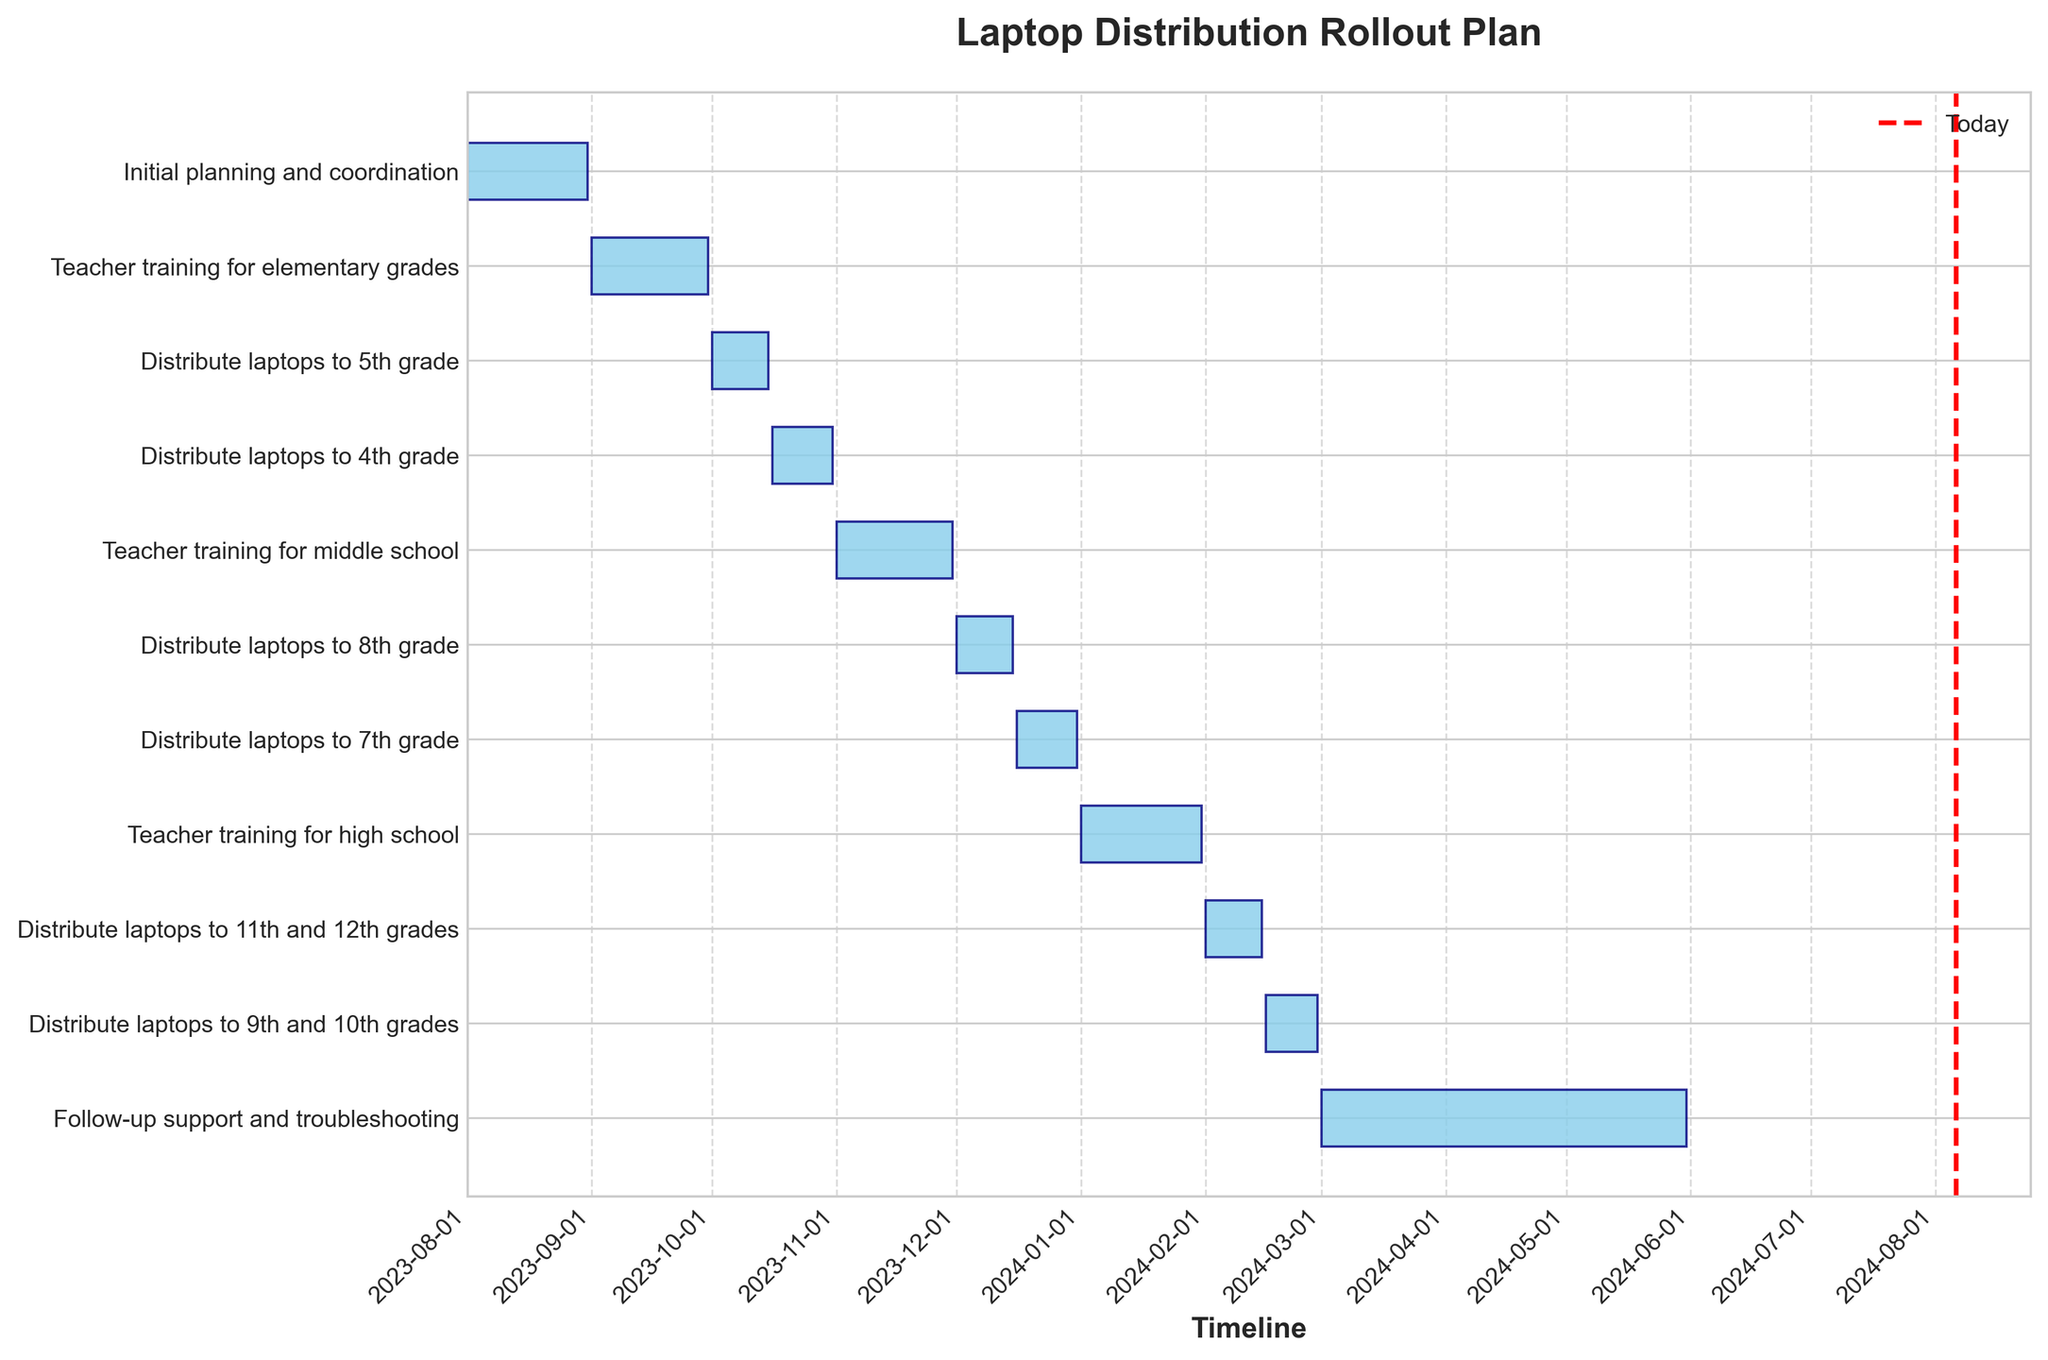What is the title of the Gantt Chart? The title of the figure is typically displayed at the top of the chart. In this case, it is "Laptop Distribution Rollout Plan" as noted in the code and data provided.
Answer: Laptop Distribution Rollout Plan Which tasks are planned for February 2024? By looking at the timeline along the x-axis, we can see the tasks that fall within the month of February 2024. These tasks are "Distribute laptops to 11th and 12th grades" and "Distribute laptops to 9th and 10th grades".
Answer: Distribute laptops to 11th and 12th grades and Distribute laptops to 9th and 10th grades How many tasks are there in total? We can count the number of horizontal bars on the Gantt Chart. Each bar represents one task. Summing them up gives the total number of tasks.
Answer: 10 What is the duration of Teacher training for middle school? The duration is the difference between the end date and the start date. "Teacher training for middle school" starts on November 1, 2023, and ends on November 30, 2023. The duration is the entire month of November.
Answer: 30 days When does the distribution of laptops to 4th grade start and end? Looking at the specific task "Distribute laptops to 4th grade" on the Y-axis, one can see its corresponding time span on the X-axis. The data indicates this task starts on October 16, 2023, and ends on October 31, 2023.
Answer: Starts on October 16, 2023, and ends on October 31, 2023 Which task has the longest duration? To find the longest task duration, compare the length of the bars on the Gantt chart. The task "Follow-up support and troubleshooting" spans from March 1, 2024, to May 31, 2024, making it the longest.
Answer: Follow-up support and troubleshooting Does the initial planning and coordination overlap with any other task? Initial planning and coordination runs from August 1, 2023, to August 31, 2023. Looking at the chart, no other bars overlap with this period, indicating no overlap with other tasks.
Answer: No What is the combined duration of all teacher training periods? Summing up the durations of "Teacher training for elementary grades", "Teacher training for middle school", and "Teacher training for high school". Each training period is one month long — September, November, and January — adding up to a total of 3 months.
Answer: 3 months Which grade levels receive laptops before December 2023? By examining the start and end dates on the Gantt chart, we can see that laptops are distributed to 5th grade and 4th grade before December 2023.
Answer: 5th grade and 4th grade Which task ends latest? Checking the end dates on the Gantt chart, the task "Follow-up support and troubleshooting" continues until May 31, 2024, making it the task with the latest end date.
Answer: Follow-up support and troubleshooting 